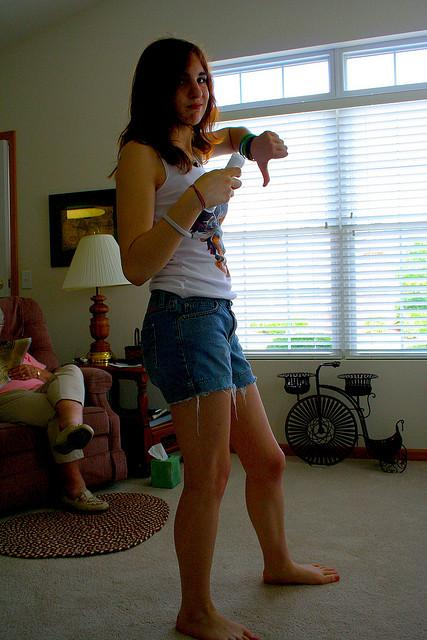What is the window covering called?

Choices:
A) panels
B) curtains
C) blinds
D) shades blinds 